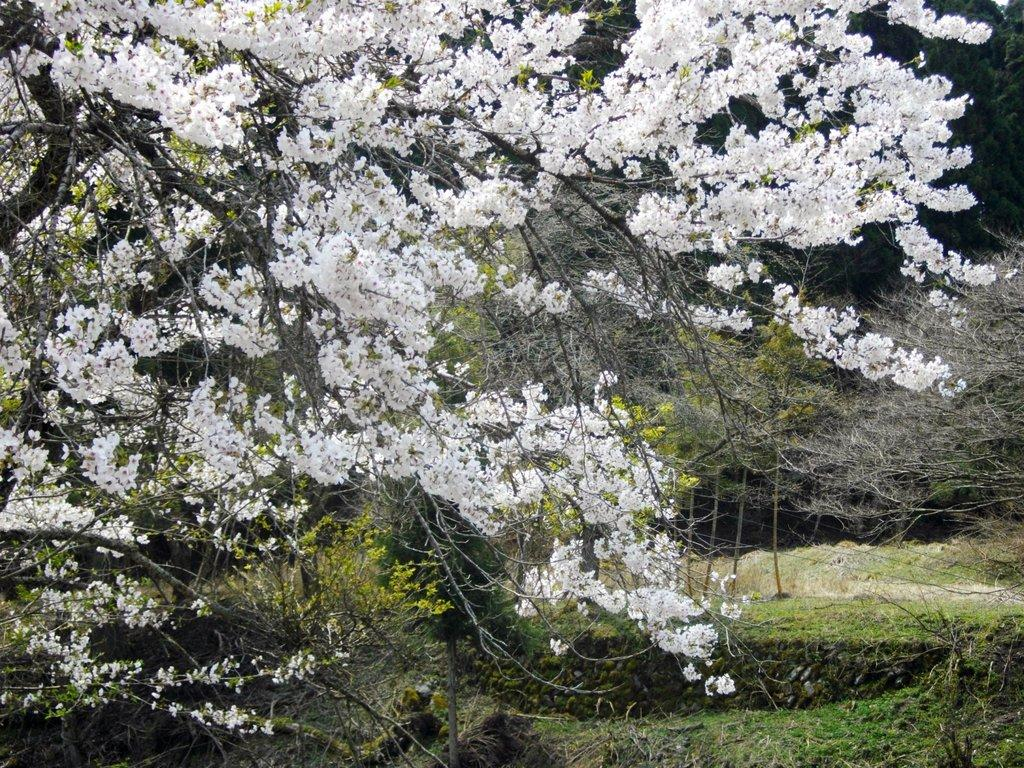What type of vegetation can be seen in the image? There are trees and flowers visible in the image. What is at the bottom of the image? There is grass at the bottom of the image. What is the opinion of the pump about the flowers in the image? There is no pump present in the image, so it is not possible to determine its opinion about the flowers. 